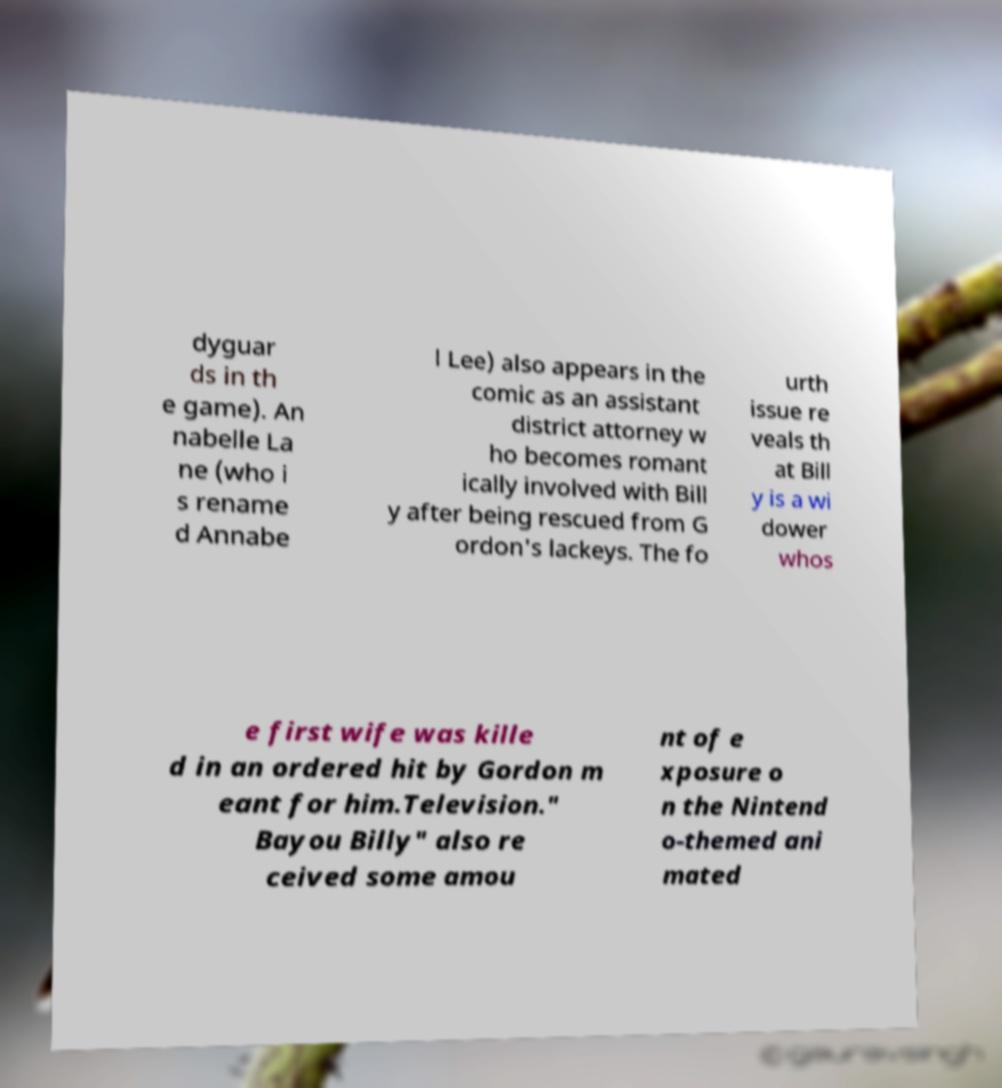There's text embedded in this image that I need extracted. Can you transcribe it verbatim? dyguar ds in th e game). An nabelle La ne (who i s rename d Annabe l Lee) also appears in the comic as an assistant district attorney w ho becomes romant ically involved with Bill y after being rescued from G ordon's lackeys. The fo urth issue re veals th at Bill y is a wi dower whos e first wife was kille d in an ordered hit by Gordon m eant for him.Television." Bayou Billy" also re ceived some amou nt of e xposure o n the Nintend o-themed ani mated 